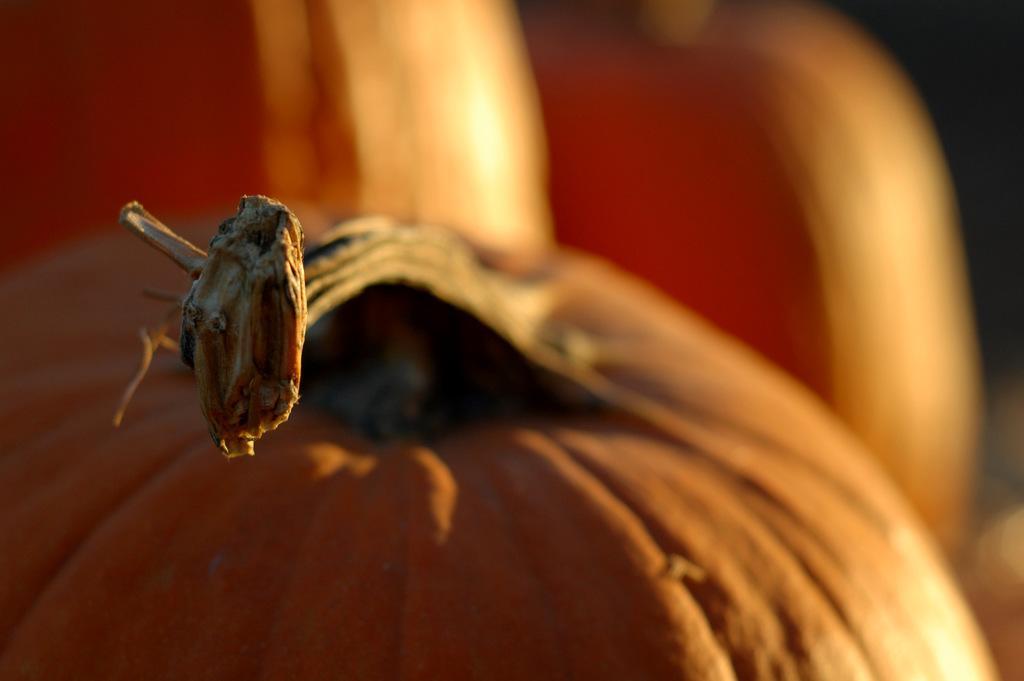Please provide a concise description of this image. Background portion of the picture is blurred. In this picture we can see pumpkins. 